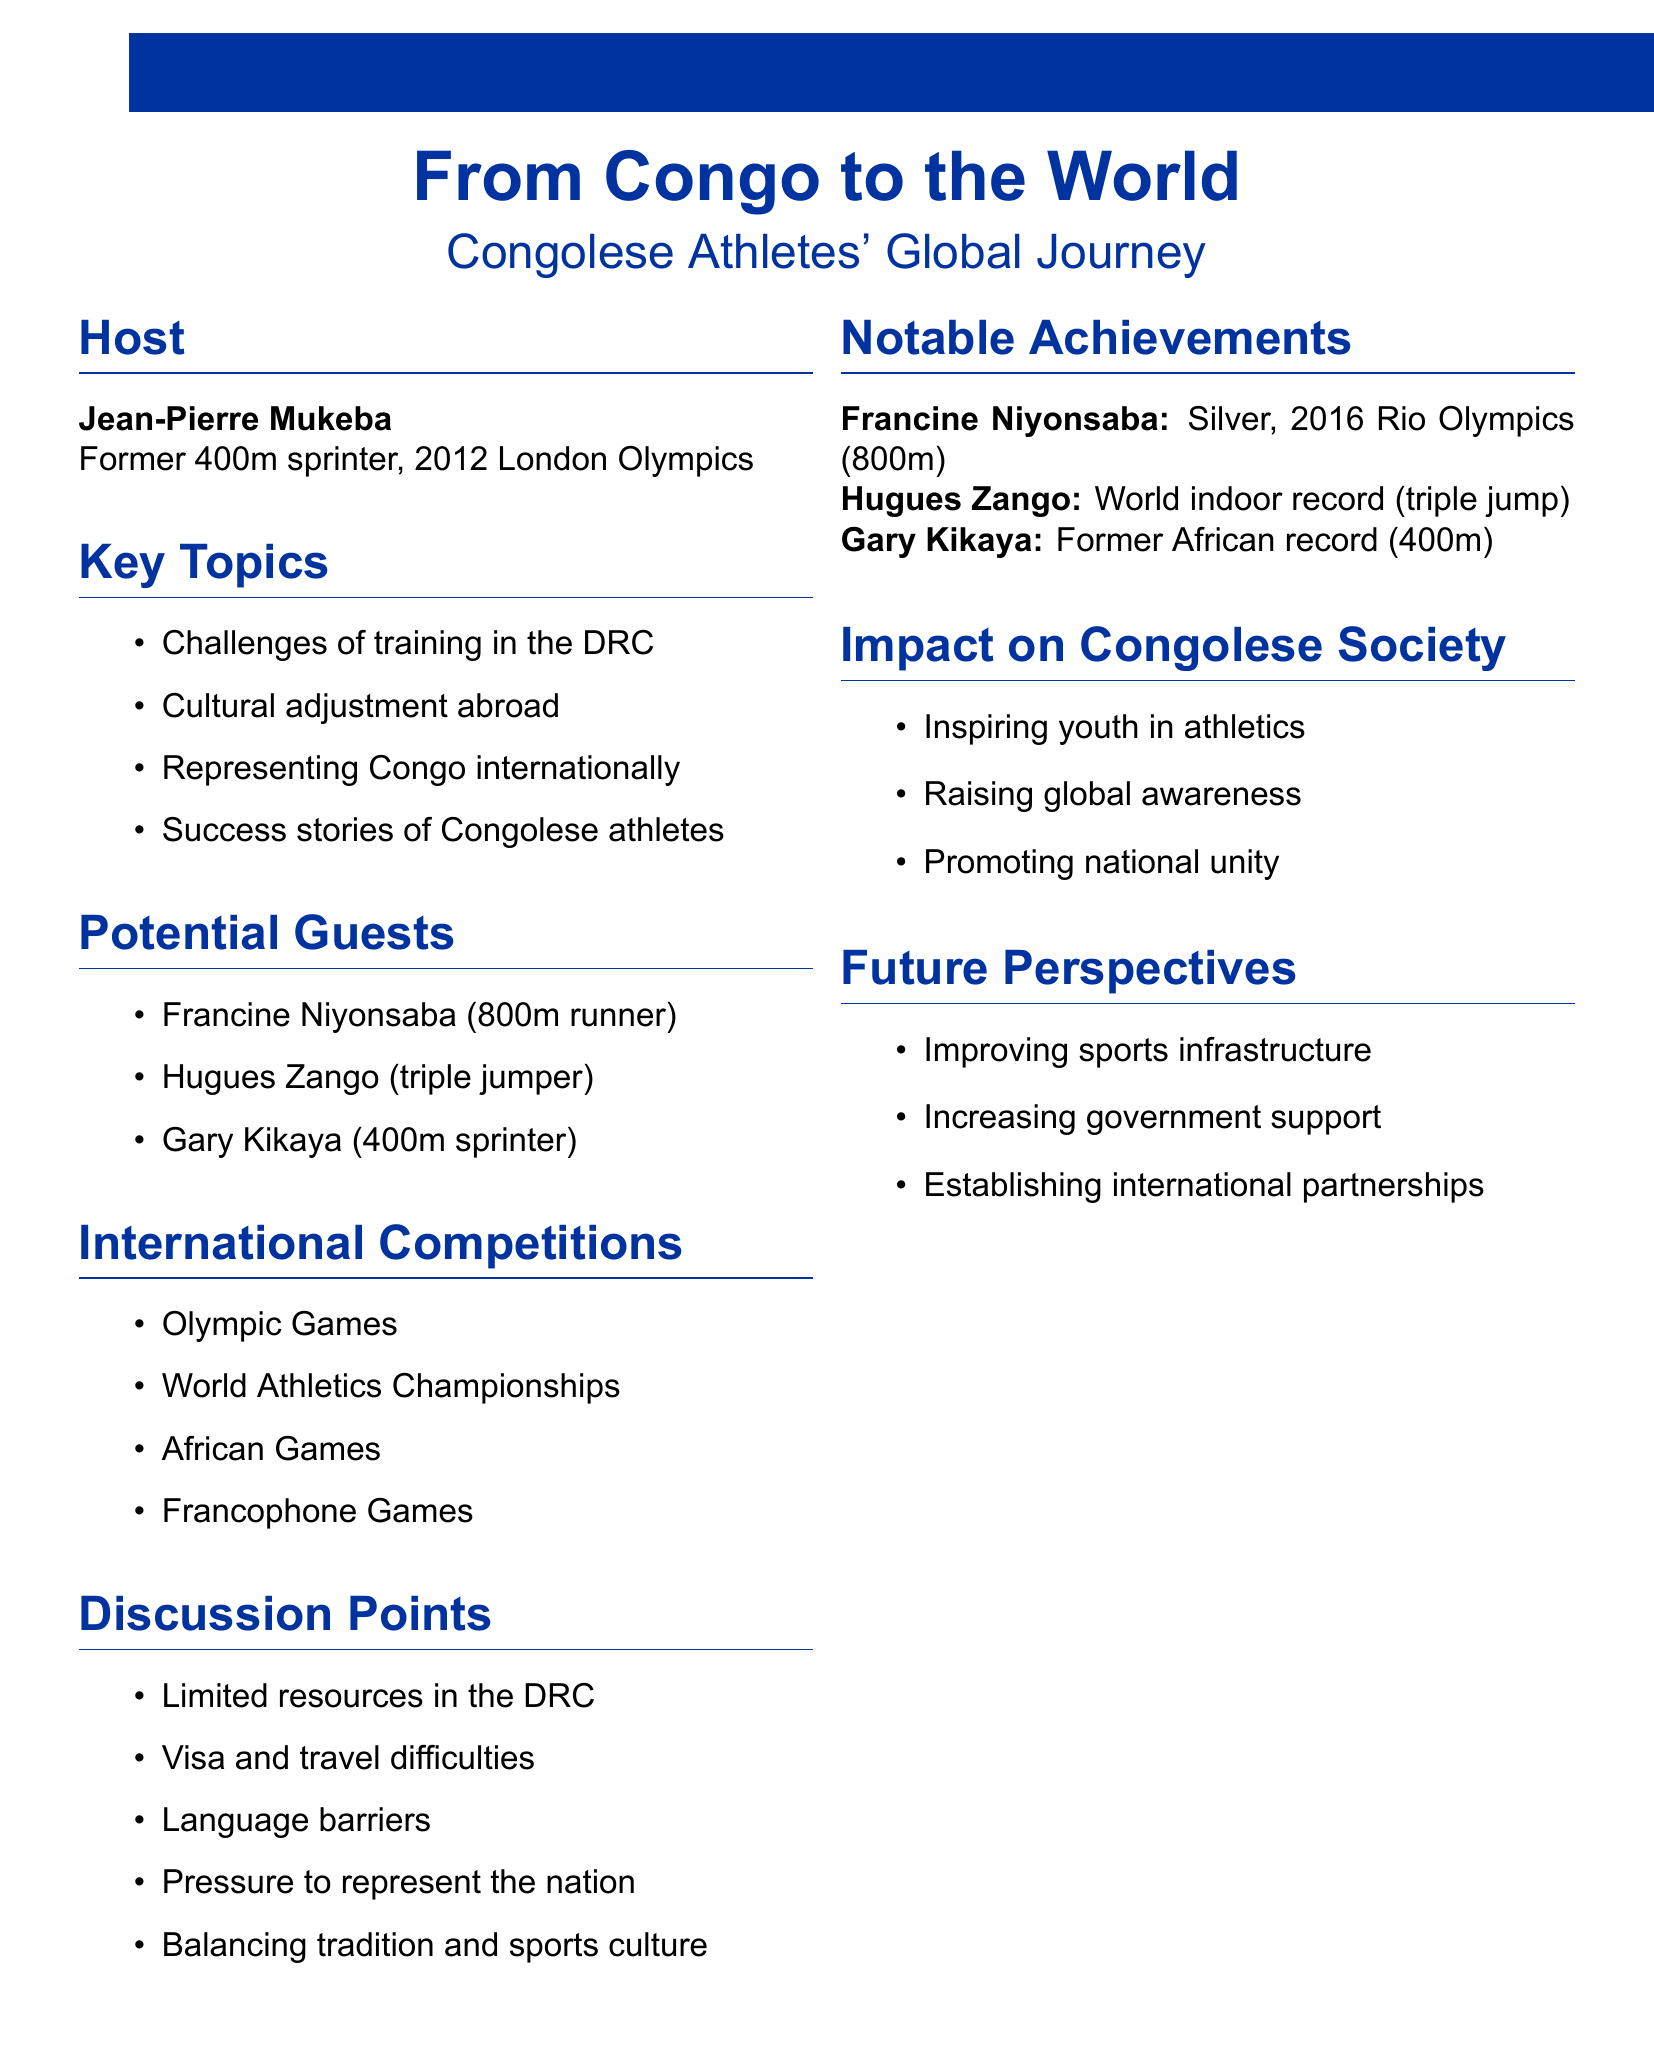What is the title of the podcast? The title of the podcast is stated clearly in the document.
Answer: From Congo to the World Who is the host of the podcast? The host is introduced in the document, mentioning their name and background.
Answer: Jean-Pierre Mukeba Which athlete won a silver medal at the 2016 Rio Olympics? The document lists notable achievements, including the silver medal winner and their event.
Answer: Francine Niyonsaba What is one key topic discussed in the podcast? Several key topics are outlined in the notes, showcasing the focus areas of the podcast.
Answer: Challenges of training in the DRC What is one impact of Congolese athletes on society? The document provides insights into the societal impact of Congolese athletes' success.
Answer: Inspiring youth to pursue athletics What is a noted challenge for athletes in the DRC? The discussion points highlight some of the challenges faced by athletes in the Democratic Republic of the Congo.
Answer: Limited resources and facilities in the DRC Name a potential guest on the podcast. The document lists potential guests who could be interviewed on the podcast.
Answer: Hugues Zango What is one future perspective mentioned in the document? Future perspectives are outlined, indicating aspirations for sports development in the DRC.
Answer: Improving sports infrastructure in the DRC 